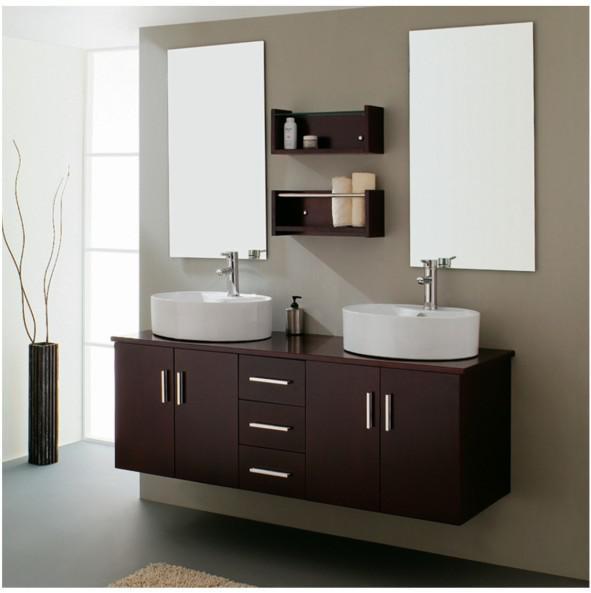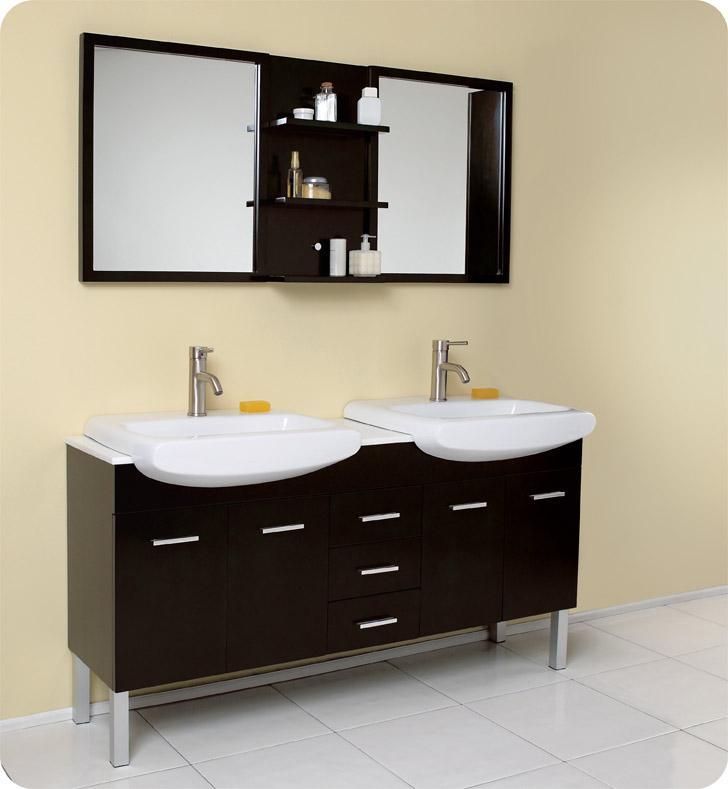The first image is the image on the left, the second image is the image on the right. Examine the images to the left and right. Is the description "Two mirrors hang over the sinks in the image on the right." accurate? Answer yes or no. Yes. 